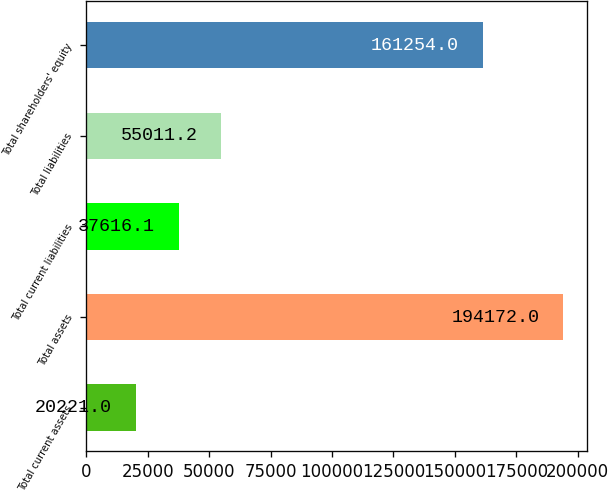Convert chart. <chart><loc_0><loc_0><loc_500><loc_500><bar_chart><fcel>Total current assets<fcel>Total assets<fcel>Total current liabilities<fcel>Total liabilities<fcel>Total shareholders' equity<nl><fcel>20221<fcel>194172<fcel>37616.1<fcel>55011.2<fcel>161254<nl></chart> 